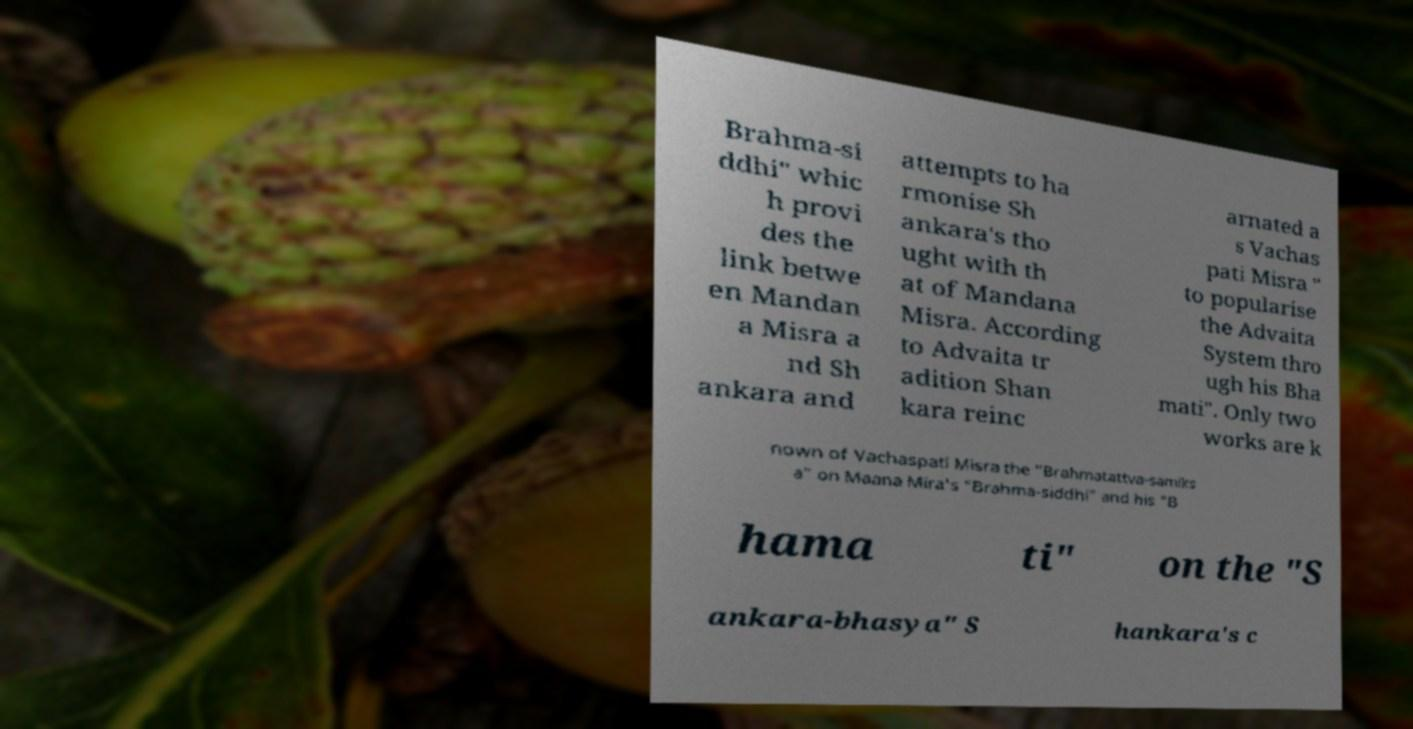Please read and relay the text visible in this image. What does it say? Brahma-si ddhi" whic h provi des the link betwe en Mandan a Misra a nd Sh ankara and attempts to ha rmonise Sh ankara's tho ught with th at of Mandana Misra. According to Advaita tr adition Shan kara reinc arnated a s Vachas pati Misra " to popularise the Advaita System thro ugh his Bha mati". Only two works are k nown of Vachaspati Misra the "Brahmatattva-samiks a" on Maana Mira's "Brahma-siddhi" and his "B hama ti" on the "S ankara-bhasya" S hankara's c 